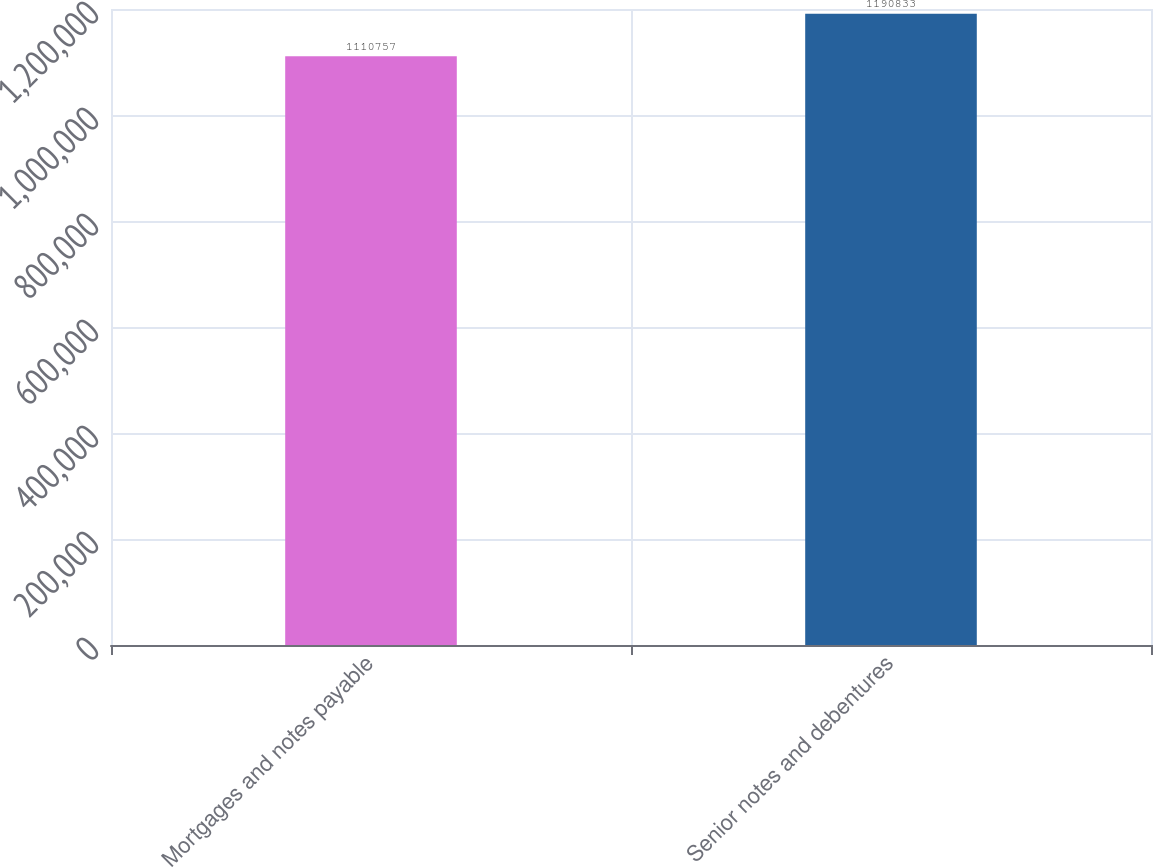Convert chart to OTSL. <chart><loc_0><loc_0><loc_500><loc_500><bar_chart><fcel>Mortgages and notes payable<fcel>Senior notes and debentures<nl><fcel>1.11076e+06<fcel>1.19083e+06<nl></chart> 